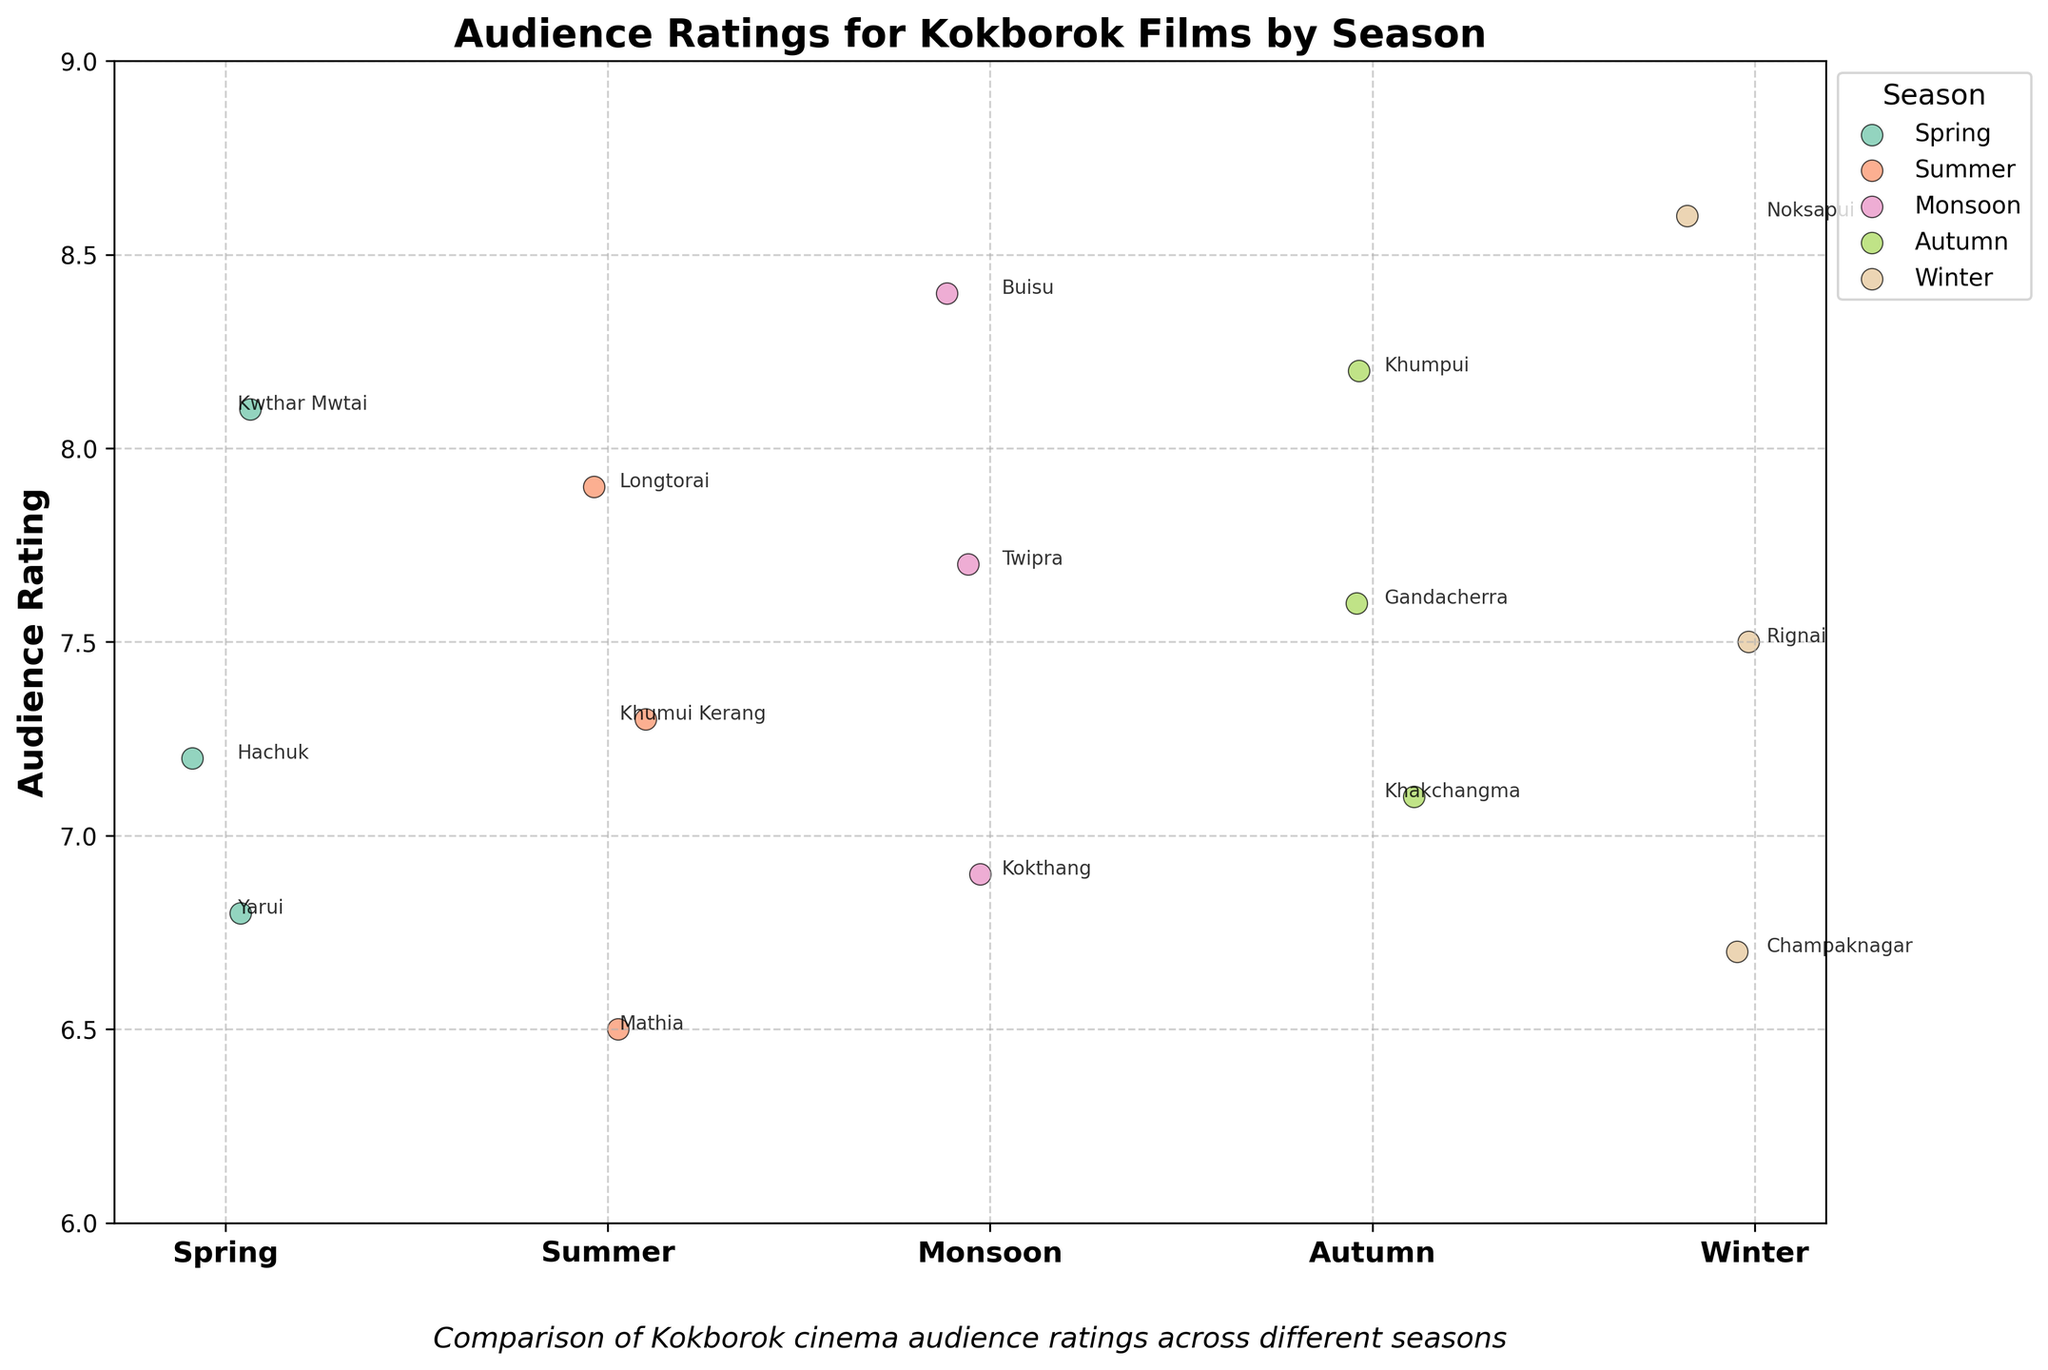How many films are represented in the strip plot? Count all the individual points (films) scattered across the seasons. The total number of films for Spring, Summer, Monsoon, Autumn, and Winter are 3, 3, 3, 3, and 3 respectively. Adding these gives a total film count.
Answer: 15 Which season has the highest average audience rating? Calculate the average audience rating for each season and compare them: Spring (7.37), Summer (7.23), Monsoon (7.67), Autumn (7.63), Winter (7.6). Monsoon has the highest average rating.
Answer: Monsoon What is the lowest audience rating and for which film and season is it? Identify the lowest rating among all the data points. The film with the lowest rating in Summer is Mathia with a rating of 6.5, which is the overall lowest.
Answer: Mathia, Summer, 6.5 Which season has the most spread in audience ratings? Calculate the spread (range) for each season: Spring (8.1 - 6.8 = 1.3), Summer (7.9 - 6.5 = 1.4), Monsoon (8.4 - 6.9 = 1.5), Autumn (8.2 - 7.1 = 1.1), Winter (8.6 - 6.7 = 1.9). Winter has the maximum spread.
Answer: Winter Which film received the highest audience rating? Identify the highest rating value and check which film corresponds to it. The highest rating is 8.6 for the film Noksapui in Winter.
Answer: Noksapui, Winter What is the overall range of audience ratings across all seasons? Compute the overall range by subtracting the minimum rating (6.5) from the maximum rating (8.6).
Answer: 2.1 Are there any films with an audience rating equal to 8.0? Check for any data points where the audience rating is exactly 8.0. There are no such data points in the given dataset.
Answer: No Which season has the most consistently high ratings? Evaluate the ratings for each season: Monsoon has all ratings above 6.9 and an average close to the higher end, indicating consistent high ratings.
Answer: Monsoon What is the title of the figure? The title is displayed prominently at the top of the figure in bold, which is "Audience Ratings for Kokborok Films by Season".
Answer: Audience Ratings for Kokborok Films by Season 